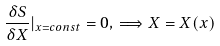<formula> <loc_0><loc_0><loc_500><loc_500>\frac { \delta S } { \delta X } | _ { x = c o n s t } = 0 , \, \Longrightarrow X = X ( x )</formula> 